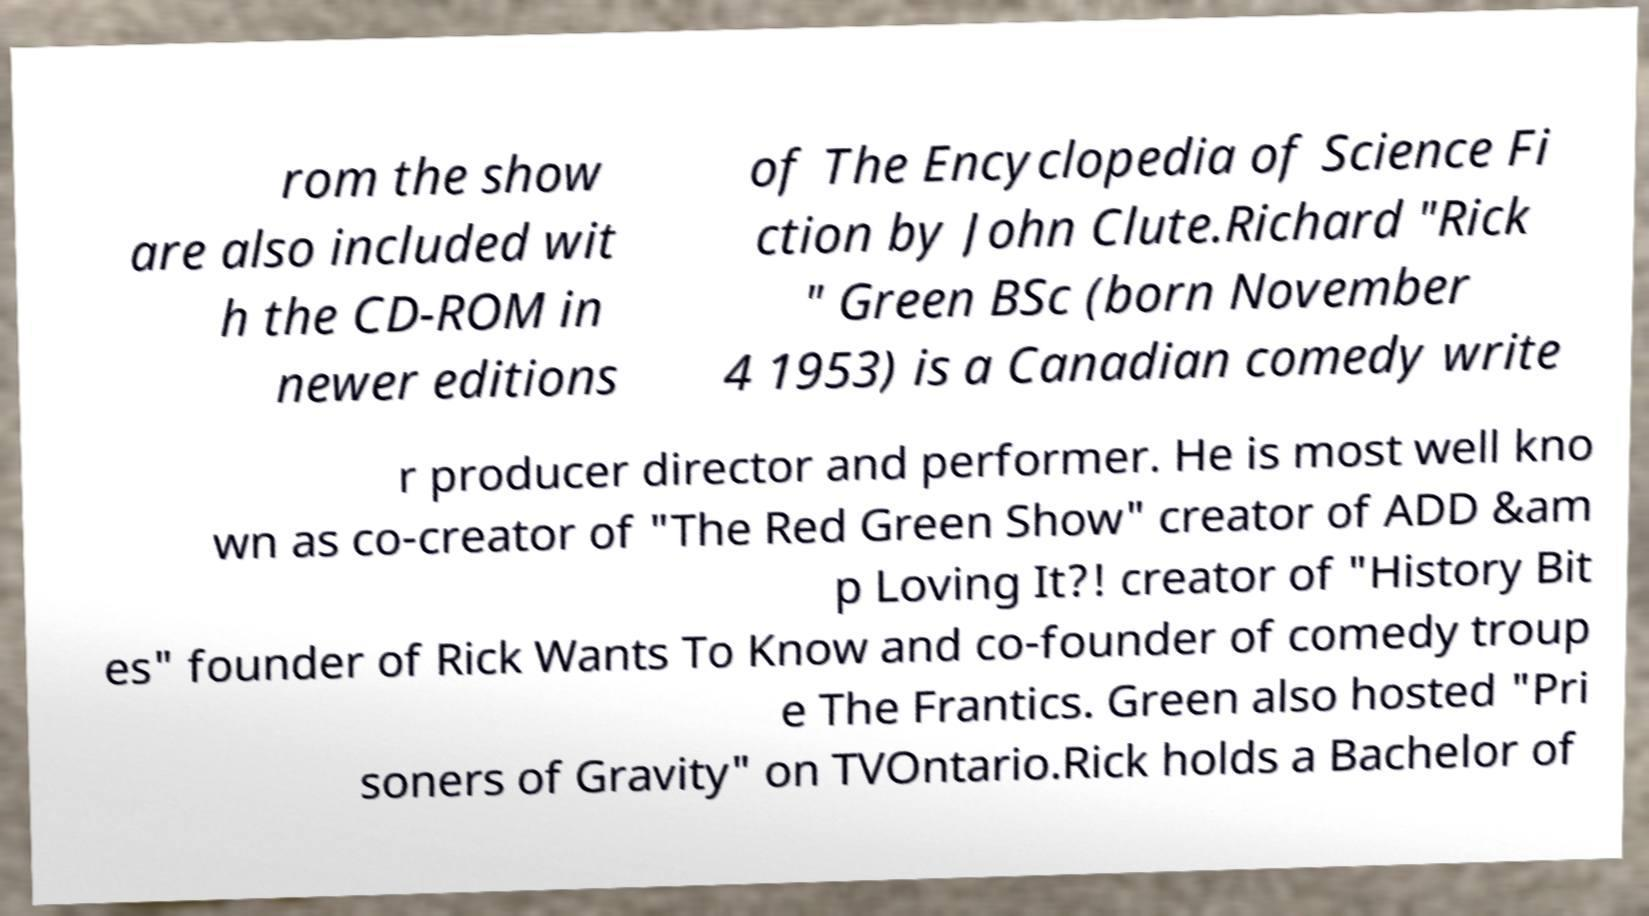Please identify and transcribe the text found in this image. rom the show are also included wit h the CD-ROM in newer editions of The Encyclopedia of Science Fi ction by John Clute.Richard "Rick " Green BSc (born November 4 1953) is a Canadian comedy write r producer director and performer. He is most well kno wn as co-creator of "The Red Green Show" creator of ADD &am p Loving It?! creator of "History Bit es" founder of Rick Wants To Know and co-founder of comedy troup e The Frantics. Green also hosted "Pri soners of Gravity" on TVOntario.Rick holds a Bachelor of 